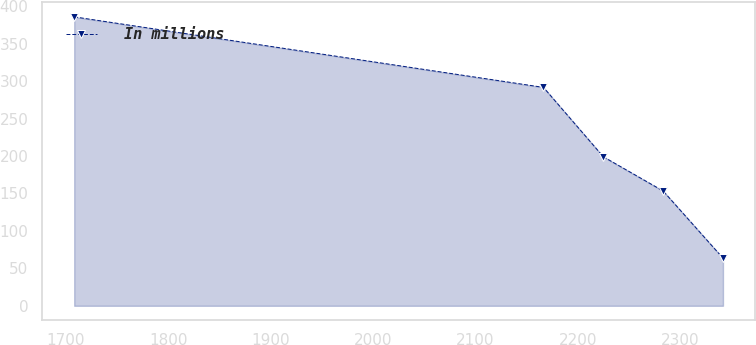Convert chart to OTSL. <chart><loc_0><loc_0><loc_500><loc_500><line_chart><ecel><fcel>In millions<nl><fcel>1708.19<fcel>385.86<nl><fcel>2166.37<fcel>291.68<nl><fcel>2224.79<fcel>199.07<nl><fcel>2283.21<fcel>153.33<nl><fcel>2341.63<fcel>63.67<nl></chart> 